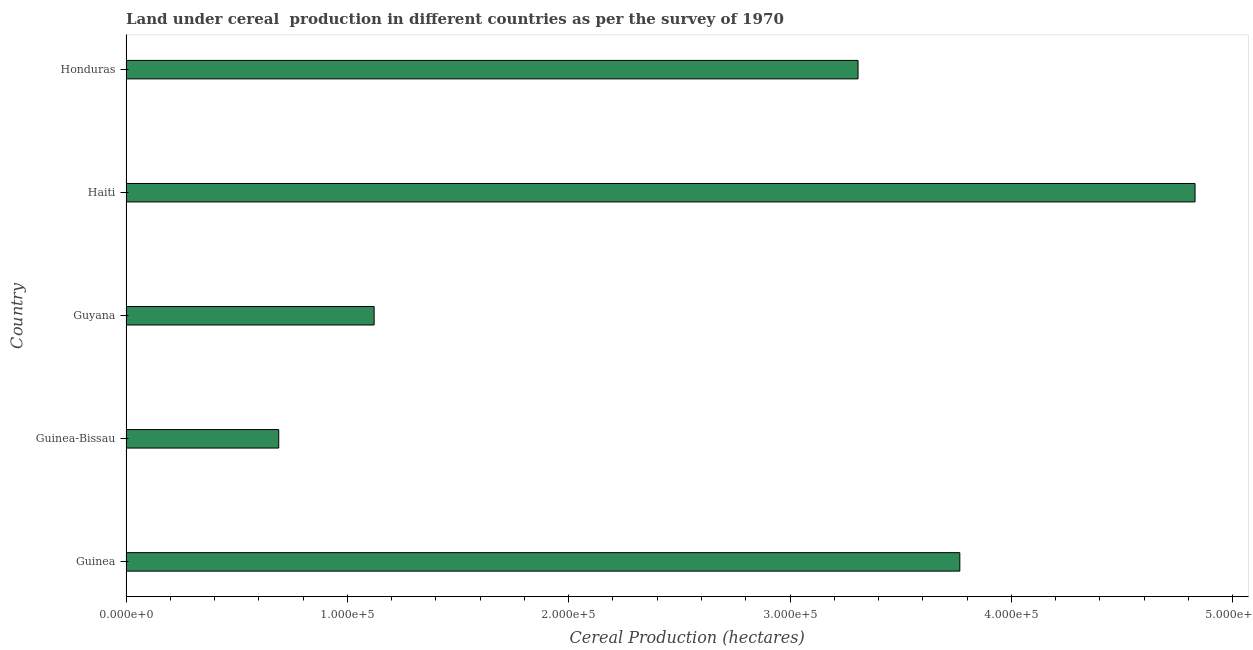What is the title of the graph?
Ensure brevity in your answer.  Land under cereal  production in different countries as per the survey of 1970. What is the label or title of the X-axis?
Make the answer very short. Cereal Production (hectares). What is the land under cereal production in Guinea?
Offer a terse response. 3.77e+05. Across all countries, what is the maximum land under cereal production?
Ensure brevity in your answer.  4.83e+05. Across all countries, what is the minimum land under cereal production?
Offer a terse response. 6.90e+04. In which country was the land under cereal production maximum?
Your answer should be very brief. Haiti. In which country was the land under cereal production minimum?
Keep it short and to the point. Guinea-Bissau. What is the sum of the land under cereal production?
Your answer should be compact. 1.37e+06. What is the difference between the land under cereal production in Guyana and Haiti?
Ensure brevity in your answer.  -3.71e+05. What is the average land under cereal production per country?
Keep it short and to the point. 2.74e+05. What is the median land under cereal production?
Provide a succinct answer. 3.31e+05. In how many countries, is the land under cereal production greater than 100000 hectares?
Provide a succinct answer. 4. What is the ratio of the land under cereal production in Guinea-Bissau to that in Guyana?
Give a very brief answer. 0.62. What is the difference between the highest and the second highest land under cereal production?
Provide a short and direct response. 1.06e+05. Is the sum of the land under cereal production in Guyana and Haiti greater than the maximum land under cereal production across all countries?
Give a very brief answer. Yes. What is the difference between the highest and the lowest land under cereal production?
Give a very brief answer. 4.14e+05. In how many countries, is the land under cereal production greater than the average land under cereal production taken over all countries?
Your response must be concise. 3. What is the Cereal Production (hectares) in Guinea?
Keep it short and to the point. 3.77e+05. What is the Cereal Production (hectares) of Guinea-Bissau?
Your answer should be compact. 6.90e+04. What is the Cereal Production (hectares) of Guyana?
Offer a terse response. 1.12e+05. What is the Cereal Production (hectares) in Haiti?
Offer a very short reply. 4.83e+05. What is the Cereal Production (hectares) of Honduras?
Provide a short and direct response. 3.31e+05. What is the difference between the Cereal Production (hectares) in Guinea and Guinea-Bissau?
Your response must be concise. 3.08e+05. What is the difference between the Cereal Production (hectares) in Guinea and Guyana?
Ensure brevity in your answer.  2.65e+05. What is the difference between the Cereal Production (hectares) in Guinea and Haiti?
Provide a short and direct response. -1.06e+05. What is the difference between the Cereal Production (hectares) in Guinea and Honduras?
Ensure brevity in your answer.  4.60e+04. What is the difference between the Cereal Production (hectares) in Guinea-Bissau and Guyana?
Offer a very short reply. -4.31e+04. What is the difference between the Cereal Production (hectares) in Guinea-Bissau and Haiti?
Provide a succinct answer. -4.14e+05. What is the difference between the Cereal Production (hectares) in Guinea-Bissau and Honduras?
Ensure brevity in your answer.  -2.62e+05. What is the difference between the Cereal Production (hectares) in Guyana and Haiti?
Provide a short and direct response. -3.71e+05. What is the difference between the Cereal Production (hectares) in Guyana and Honduras?
Provide a short and direct response. -2.19e+05. What is the difference between the Cereal Production (hectares) in Haiti and Honduras?
Provide a short and direct response. 1.52e+05. What is the ratio of the Cereal Production (hectares) in Guinea to that in Guinea-Bissau?
Provide a short and direct response. 5.46. What is the ratio of the Cereal Production (hectares) in Guinea to that in Guyana?
Make the answer very short. 3.36. What is the ratio of the Cereal Production (hectares) in Guinea to that in Haiti?
Your answer should be very brief. 0.78. What is the ratio of the Cereal Production (hectares) in Guinea to that in Honduras?
Your answer should be very brief. 1.14. What is the ratio of the Cereal Production (hectares) in Guinea-Bissau to that in Guyana?
Keep it short and to the point. 0.62. What is the ratio of the Cereal Production (hectares) in Guinea-Bissau to that in Haiti?
Make the answer very short. 0.14. What is the ratio of the Cereal Production (hectares) in Guinea-Bissau to that in Honduras?
Ensure brevity in your answer.  0.21. What is the ratio of the Cereal Production (hectares) in Guyana to that in Haiti?
Make the answer very short. 0.23. What is the ratio of the Cereal Production (hectares) in Guyana to that in Honduras?
Make the answer very short. 0.34. What is the ratio of the Cereal Production (hectares) in Haiti to that in Honduras?
Provide a succinct answer. 1.46. 